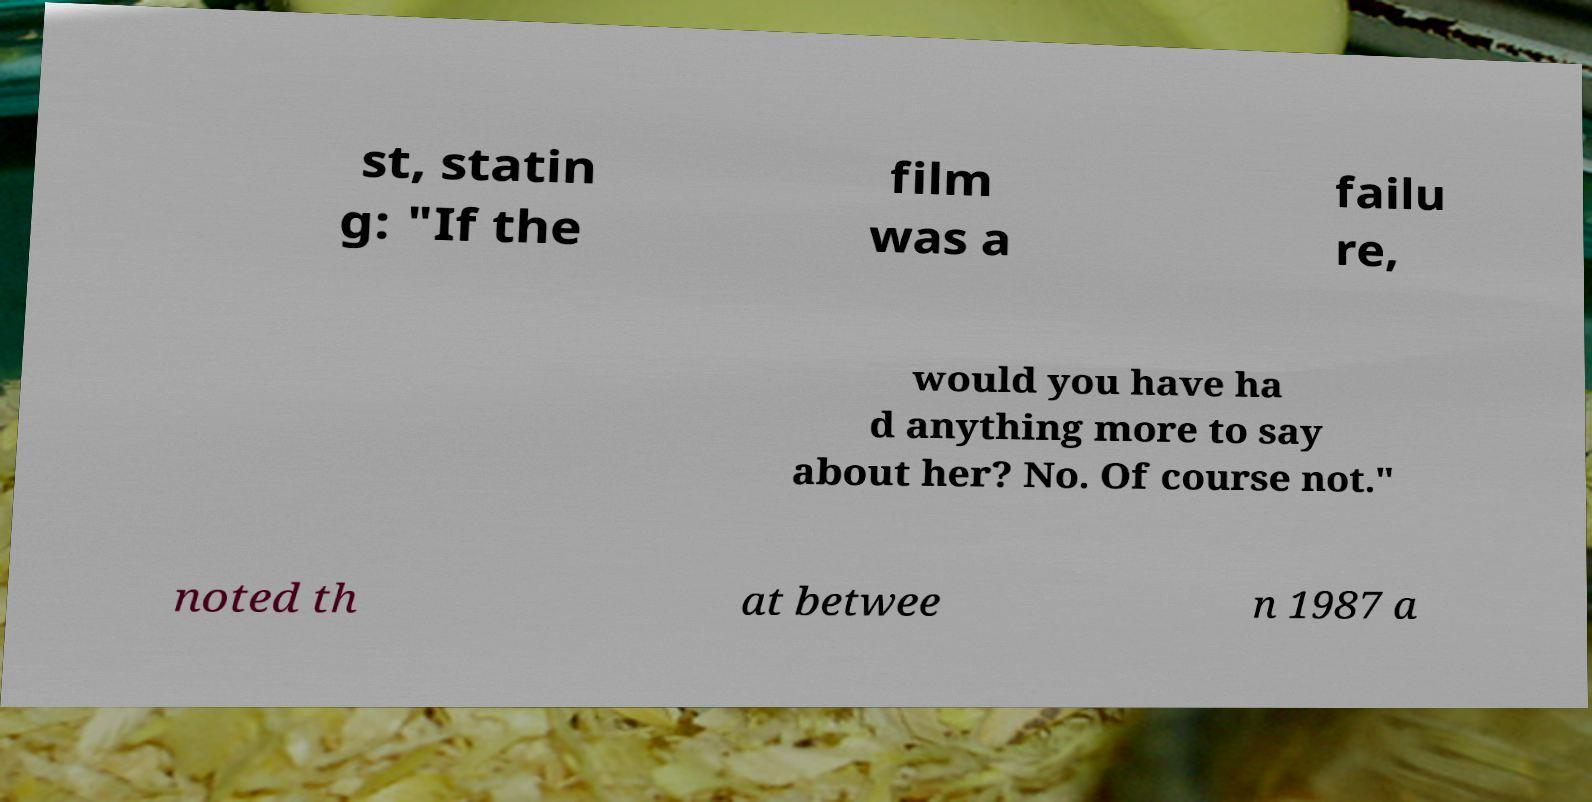Please identify and transcribe the text found in this image. st, statin g: "If the film was a failu re, would you have ha d anything more to say about her? No. Of course not." noted th at betwee n 1987 a 